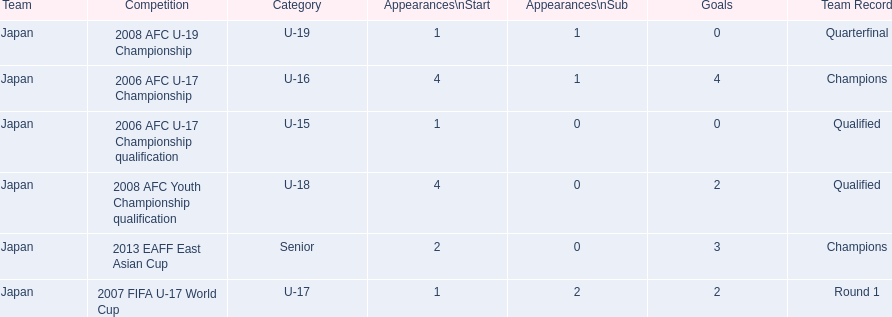Which competitions had champions team records? 2006 AFC U-17 Championship, 2013 EAFF East Asian Cup. Of these competitions, which one was in the senior category? 2013 EAFF East Asian Cup. 